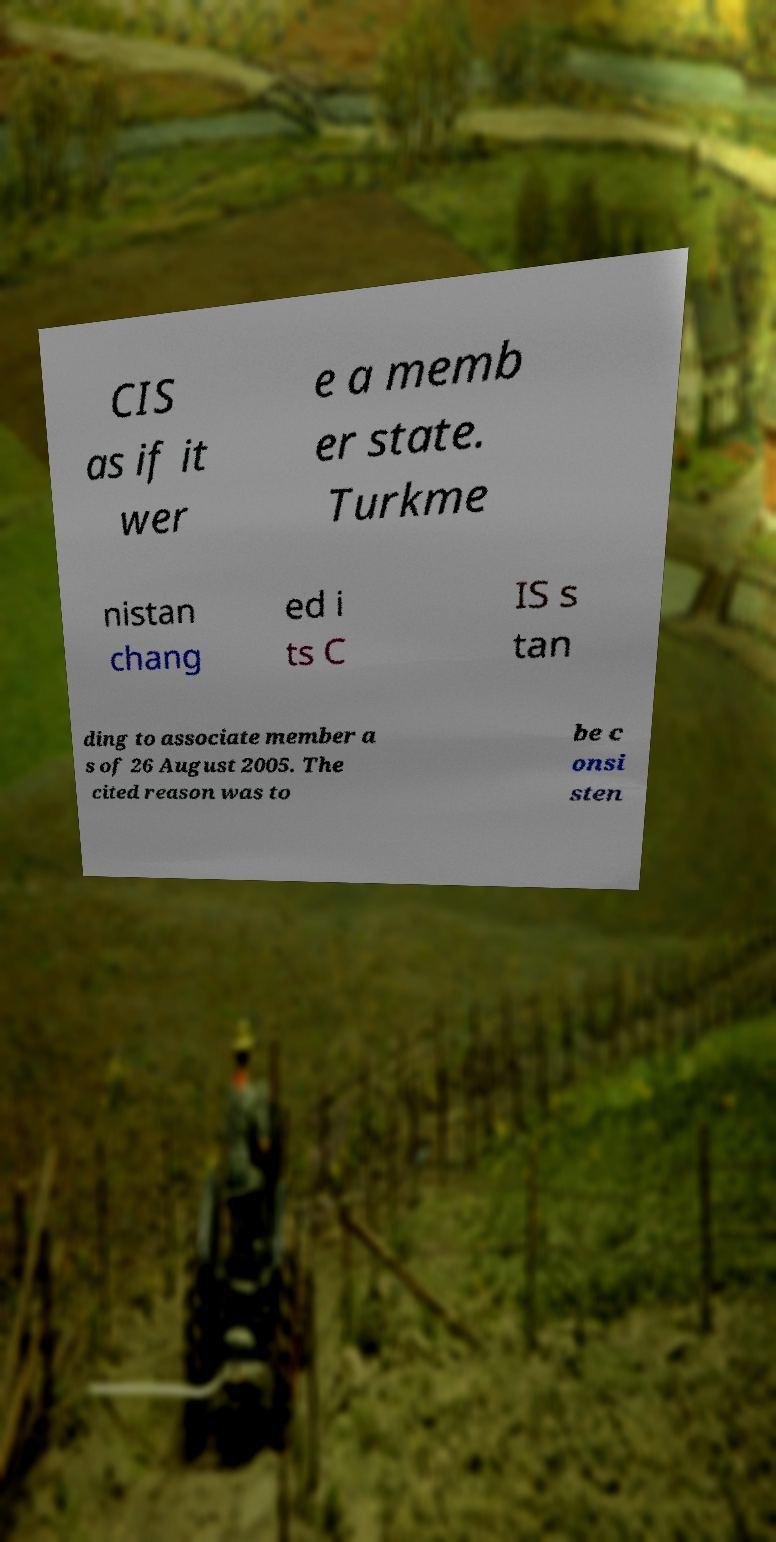Please read and relay the text visible in this image. What does it say? CIS as if it wer e a memb er state. Turkme nistan chang ed i ts C IS s tan ding to associate member a s of 26 August 2005. The cited reason was to be c onsi sten 